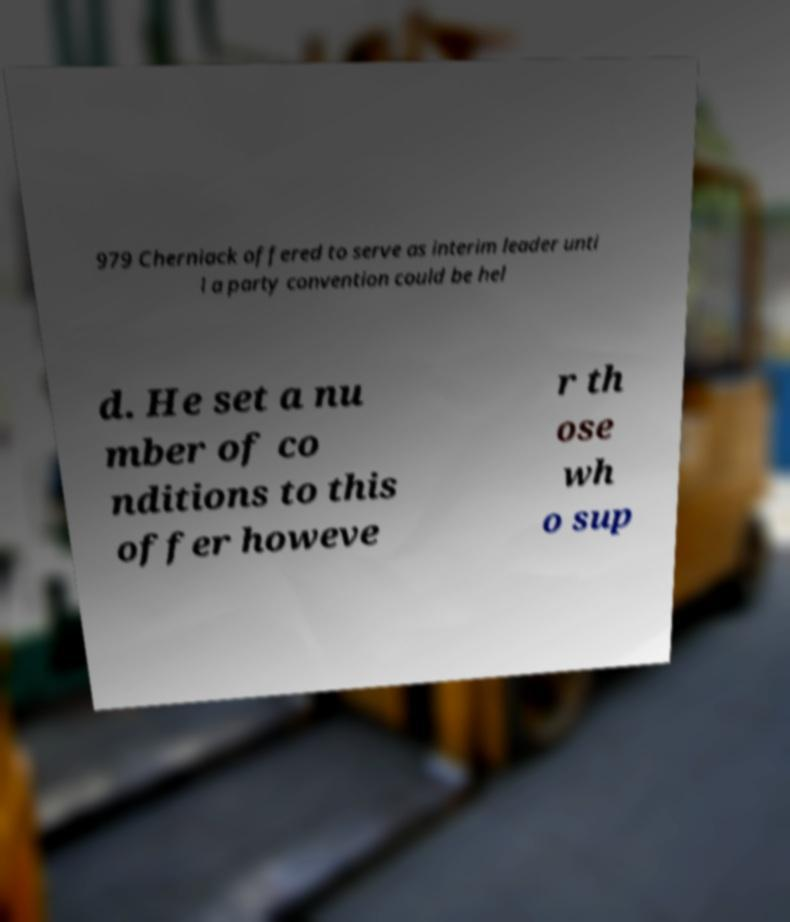For documentation purposes, I need the text within this image transcribed. Could you provide that? 979 Cherniack offered to serve as interim leader unti l a party convention could be hel d. He set a nu mber of co nditions to this offer howeve r th ose wh o sup 